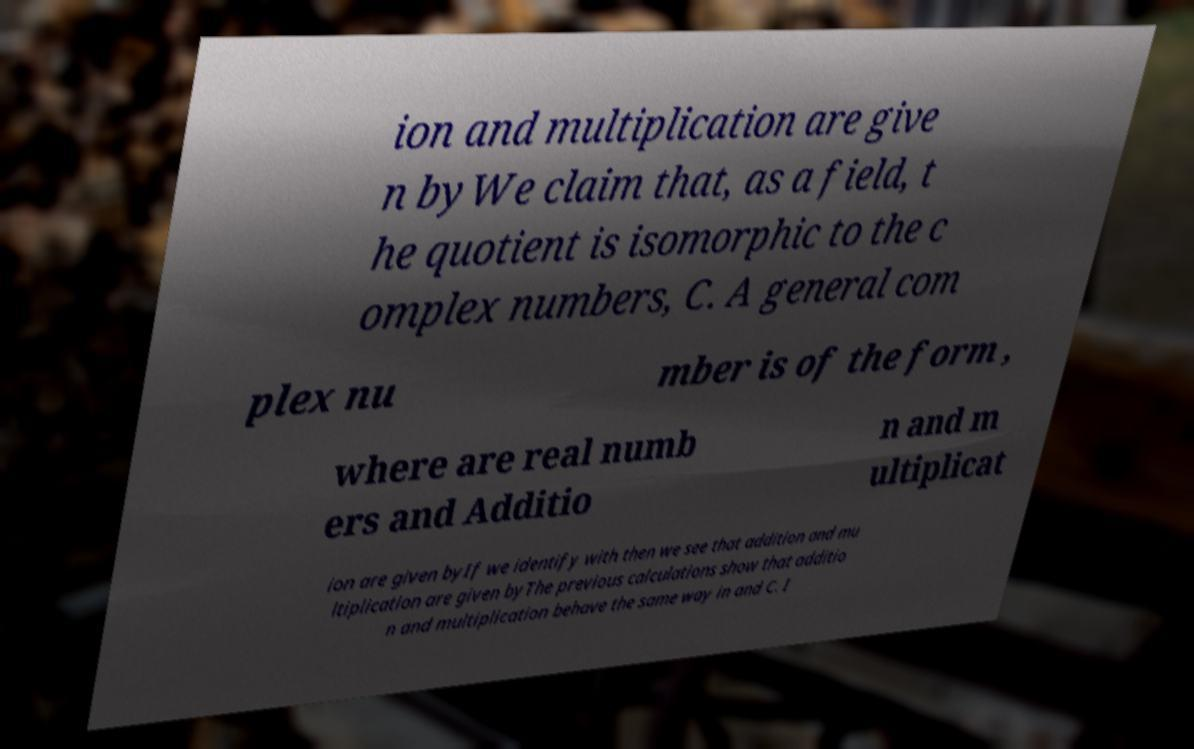What messages or text are displayed in this image? I need them in a readable, typed format. ion and multiplication are give n byWe claim that, as a field, t he quotient is isomorphic to the c omplex numbers, C. A general com plex nu mber is of the form , where are real numb ers and Additio n and m ultiplicat ion are given byIf we identify with then we see that addition and mu ltiplication are given byThe previous calculations show that additio n and multiplication behave the same way in and C. I 